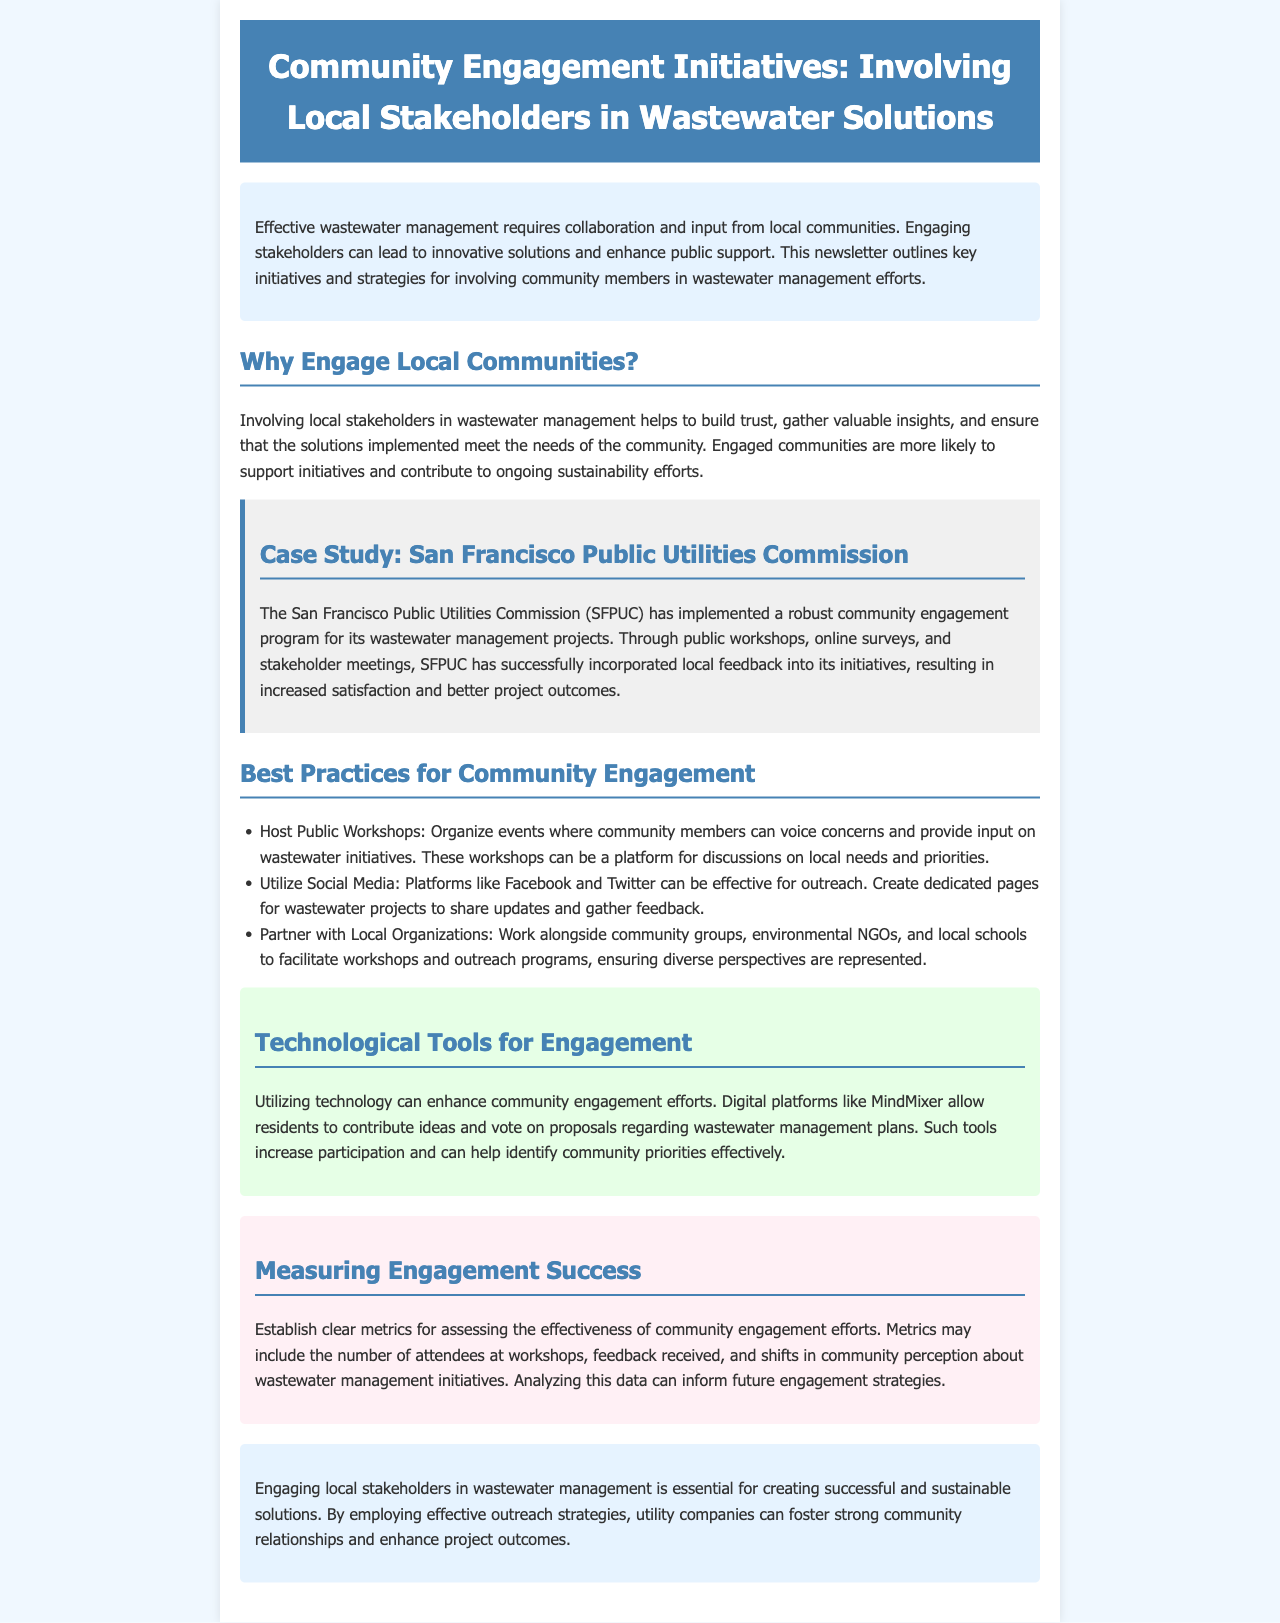What is the title of the newsletter? The title of the newsletter is stated prominently at the top as "Community Engagement Initiatives: Involving Local Stakeholders in Wastewater Solutions."
Answer: Community Engagement Initiatives: Involving Local Stakeholders in Wastewater Solutions What organization is featured in the case study? The document specifies the organization featured in the case study as the San Francisco Public Utilities Commission.
Answer: San Francisco Public Utilities Commission What are two methods suggested for community engagement? The document lists various methods for community engagement, among which hosting public workshops and utilizing social media are explicitly mentioned.
Answer: Hosting Public Workshops, Utilizing Social Media What platform is suggested for digital engagement in the document? The document names MindMixer as a digital platform that can enhance community engagement efforts.
Answer: MindMixer What is one metric for measuring engagement success mentioned? The document outlines several metrics, including the number of attendees at workshops, as a way to assess the effectiveness of engagement efforts.
Answer: Number of attendees at workshops Why is engaging local communities considered important? The document states that engaging local communities is important for building trust, gathering insights, and ensuring solutions meet community needs.
Answer: Building trust, gathering insights, ensuring solutions meet community needs How many best practices for community engagement are listed? The document specifies three best practices for community engagement under a dedicated section.
Answer: Three What is the conclusion of the newsletter about community engagement? The conclusion emphasizes that engaging local stakeholders is essential for successful and sustainable wastewater management solutions.
Answer: Essential for successful and sustainable solutions 